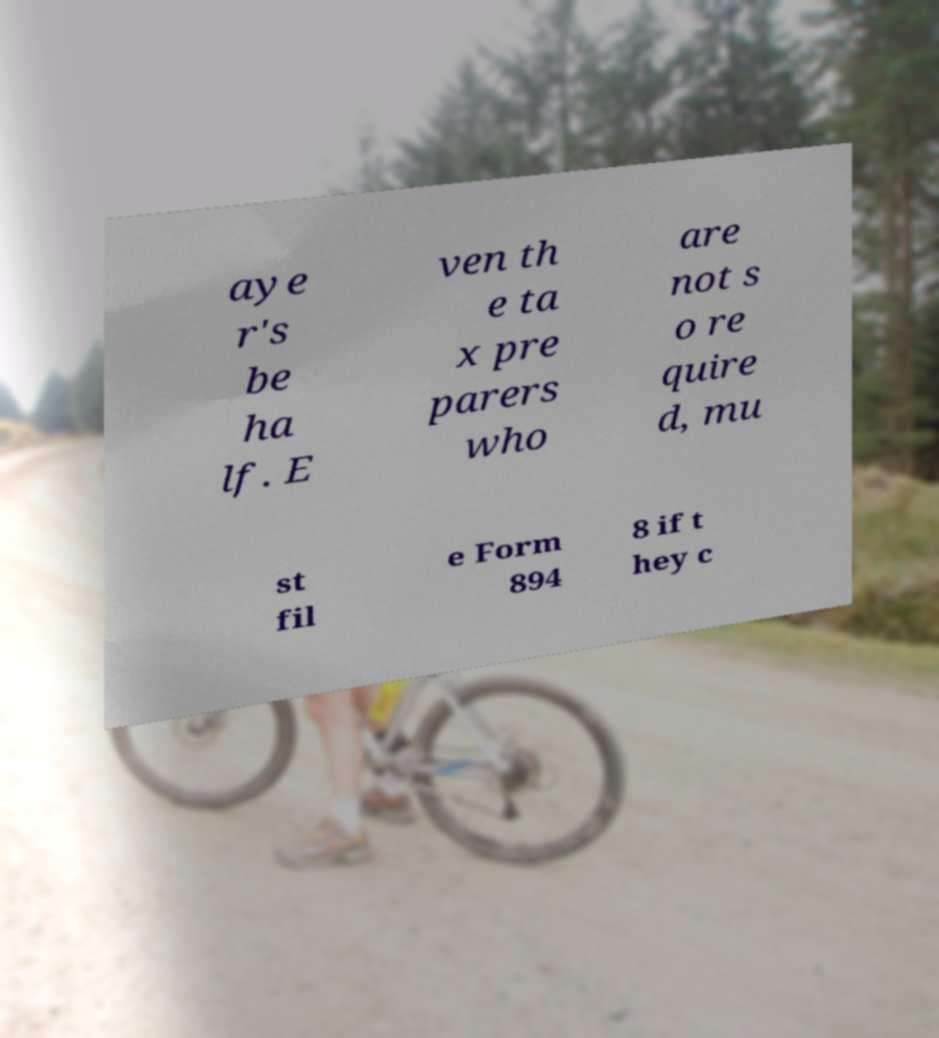For documentation purposes, I need the text within this image transcribed. Could you provide that? aye r's be ha lf. E ven th e ta x pre parers who are not s o re quire d, mu st fil e Form 894 8 if t hey c 